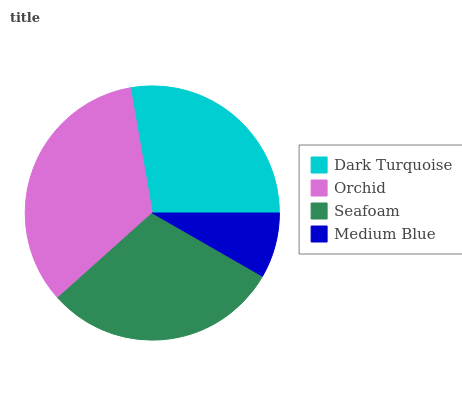Is Medium Blue the minimum?
Answer yes or no. Yes. Is Orchid the maximum?
Answer yes or no. Yes. Is Seafoam the minimum?
Answer yes or no. No. Is Seafoam the maximum?
Answer yes or no. No. Is Orchid greater than Seafoam?
Answer yes or no. Yes. Is Seafoam less than Orchid?
Answer yes or no. Yes. Is Seafoam greater than Orchid?
Answer yes or no. No. Is Orchid less than Seafoam?
Answer yes or no. No. Is Seafoam the high median?
Answer yes or no. Yes. Is Dark Turquoise the low median?
Answer yes or no. Yes. Is Orchid the high median?
Answer yes or no. No. Is Medium Blue the low median?
Answer yes or no. No. 